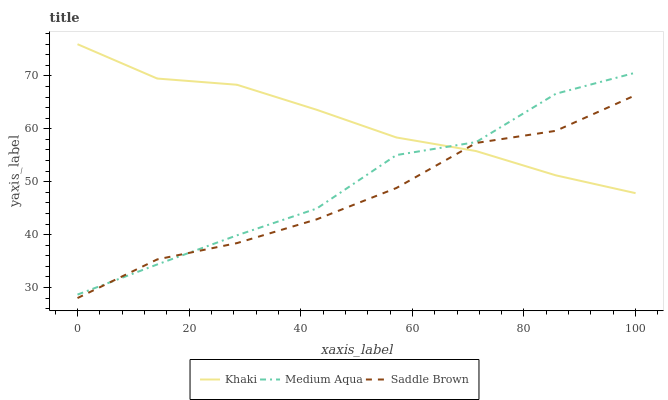Does Saddle Brown have the minimum area under the curve?
Answer yes or no. Yes. Does Khaki have the maximum area under the curve?
Answer yes or no. Yes. Does Medium Aqua have the minimum area under the curve?
Answer yes or no. No. Does Medium Aqua have the maximum area under the curve?
Answer yes or no. No. Is Khaki the smoothest?
Answer yes or no. Yes. Is Medium Aqua the roughest?
Answer yes or no. Yes. Is Saddle Brown the smoothest?
Answer yes or no. No. Is Saddle Brown the roughest?
Answer yes or no. No. Does Medium Aqua have the lowest value?
Answer yes or no. No. Does Medium Aqua have the highest value?
Answer yes or no. No. 